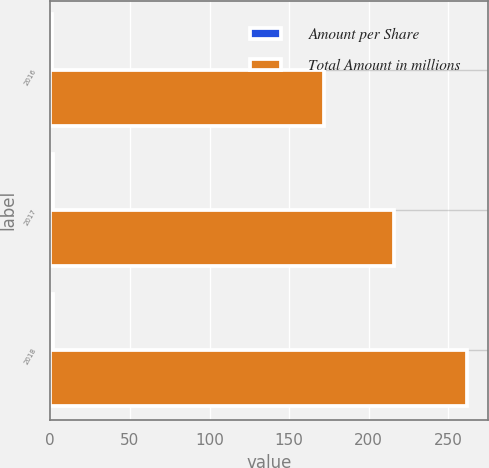Convert chart to OTSL. <chart><loc_0><loc_0><loc_500><loc_500><stacked_bar_chart><ecel><fcel>2016<fcel>2017<fcel>2018<nl><fcel>Amount per Share<fcel>1.16<fcel>1.49<fcel>1.9<nl><fcel>Total Amount in millions<fcel>172<fcel>216<fcel>262<nl></chart> 